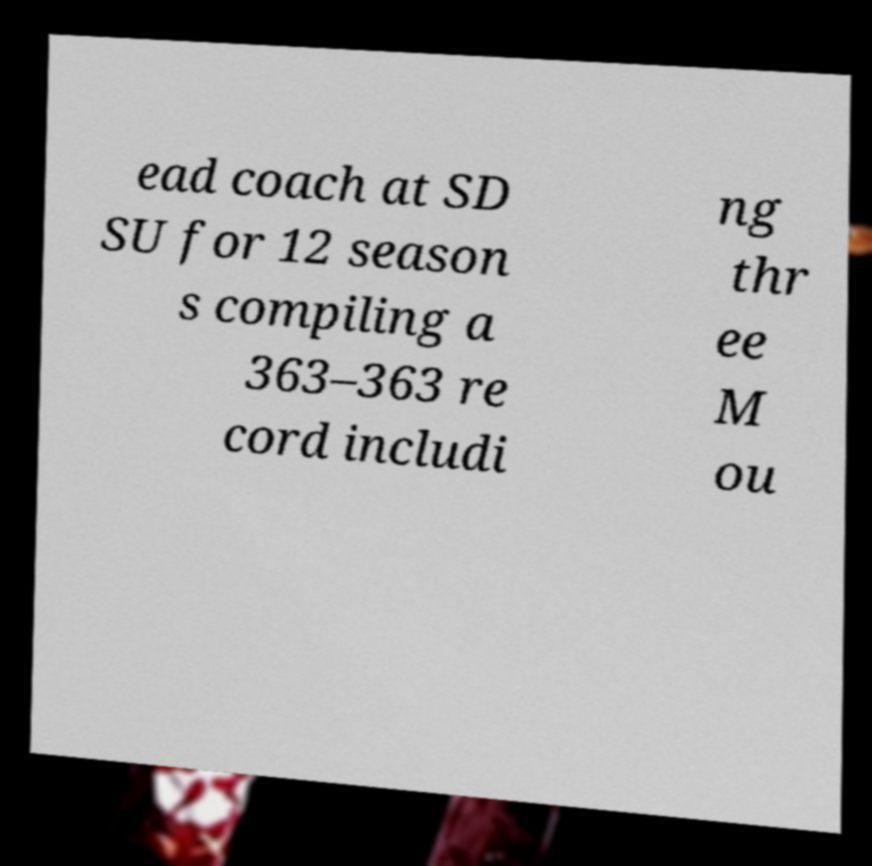Can you accurately transcribe the text from the provided image for me? ead coach at SD SU for 12 season s compiling a 363–363 re cord includi ng thr ee M ou 